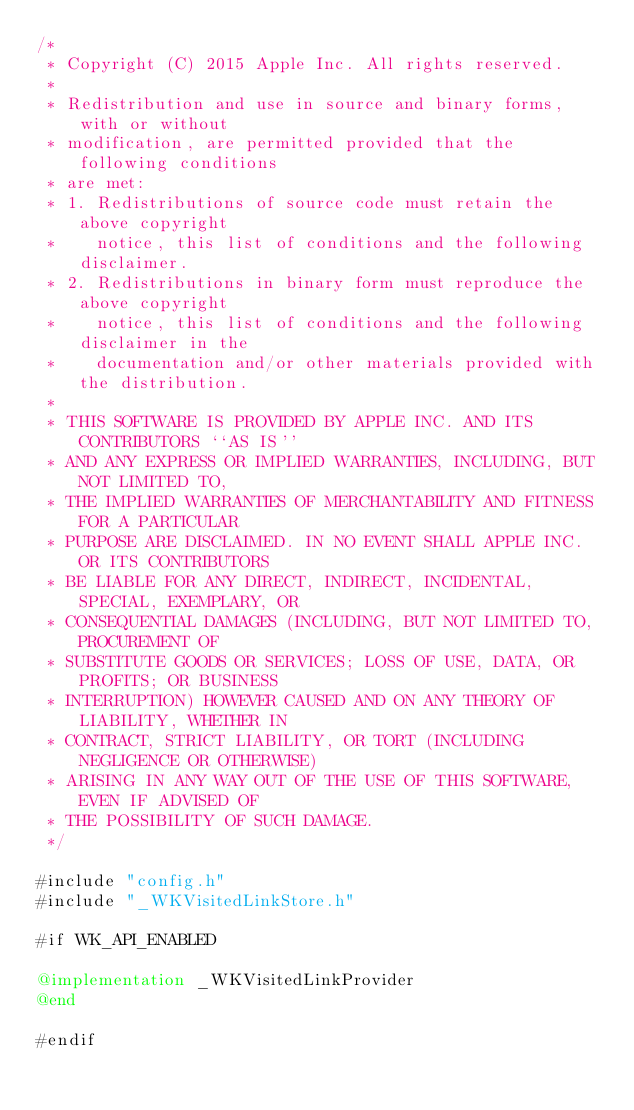Convert code to text. <code><loc_0><loc_0><loc_500><loc_500><_ObjectiveC_>/*
 * Copyright (C) 2015 Apple Inc. All rights reserved.
 *
 * Redistribution and use in source and binary forms, with or without
 * modification, are permitted provided that the following conditions
 * are met:
 * 1. Redistributions of source code must retain the above copyright
 *    notice, this list of conditions and the following disclaimer.
 * 2. Redistributions in binary form must reproduce the above copyright
 *    notice, this list of conditions and the following disclaimer in the
 *    documentation and/or other materials provided with the distribution.
 *
 * THIS SOFTWARE IS PROVIDED BY APPLE INC. AND ITS CONTRIBUTORS ``AS IS''
 * AND ANY EXPRESS OR IMPLIED WARRANTIES, INCLUDING, BUT NOT LIMITED TO,
 * THE IMPLIED WARRANTIES OF MERCHANTABILITY AND FITNESS FOR A PARTICULAR
 * PURPOSE ARE DISCLAIMED. IN NO EVENT SHALL APPLE INC. OR ITS CONTRIBUTORS
 * BE LIABLE FOR ANY DIRECT, INDIRECT, INCIDENTAL, SPECIAL, EXEMPLARY, OR
 * CONSEQUENTIAL DAMAGES (INCLUDING, BUT NOT LIMITED TO, PROCUREMENT OF
 * SUBSTITUTE GOODS OR SERVICES; LOSS OF USE, DATA, OR PROFITS; OR BUSINESS
 * INTERRUPTION) HOWEVER CAUSED AND ON ANY THEORY OF LIABILITY, WHETHER IN
 * CONTRACT, STRICT LIABILITY, OR TORT (INCLUDING NEGLIGENCE OR OTHERWISE)
 * ARISING IN ANY WAY OUT OF THE USE OF THIS SOFTWARE, EVEN IF ADVISED OF
 * THE POSSIBILITY OF SUCH DAMAGE.
 */

#include "config.h"
#include "_WKVisitedLinkStore.h"

#if WK_API_ENABLED

@implementation _WKVisitedLinkProvider
@end

#endif
</code> 